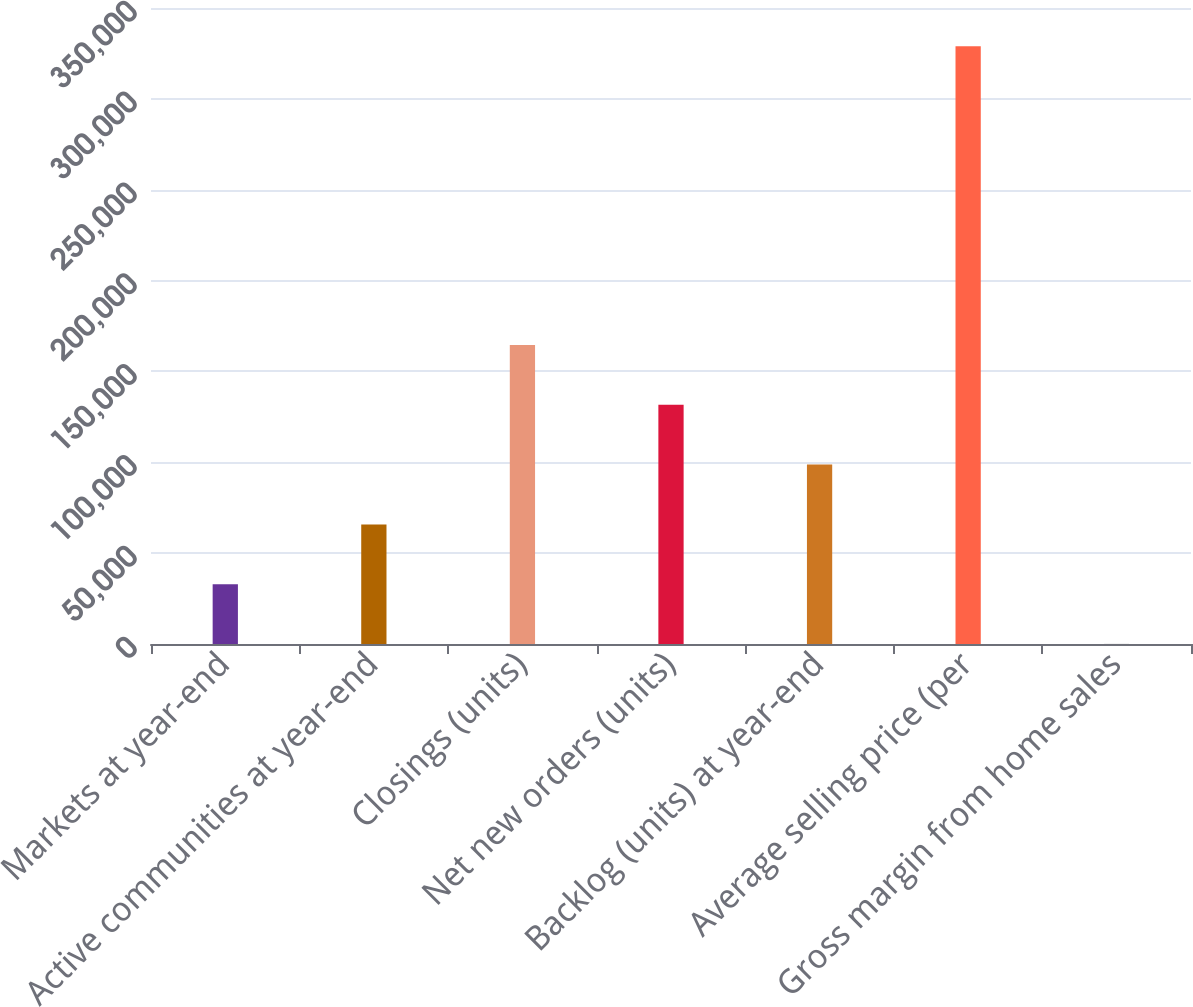Convert chart. <chart><loc_0><loc_0><loc_500><loc_500><bar_chart><fcel>Markets at year-end<fcel>Active communities at year-end<fcel>Closings (units)<fcel>Net new orders (units)<fcel>Backlog (units) at year-end<fcel>Average selling price (per<fcel>Gross margin from home sales<nl><fcel>32924<fcel>65821.4<fcel>164513<fcel>131616<fcel>98718.7<fcel>329000<fcel>26.7<nl></chart> 